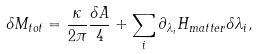Convert formula to latex. <formula><loc_0><loc_0><loc_500><loc_500>\delta M _ { t o t } = { \frac { \kappa } { 2 \pi } } { \frac { \delta A } { 4 } } + \sum _ { i } \partial _ { \lambda _ { i } } H _ { m a t t e r } \delta \lambda _ { i } ,</formula> 